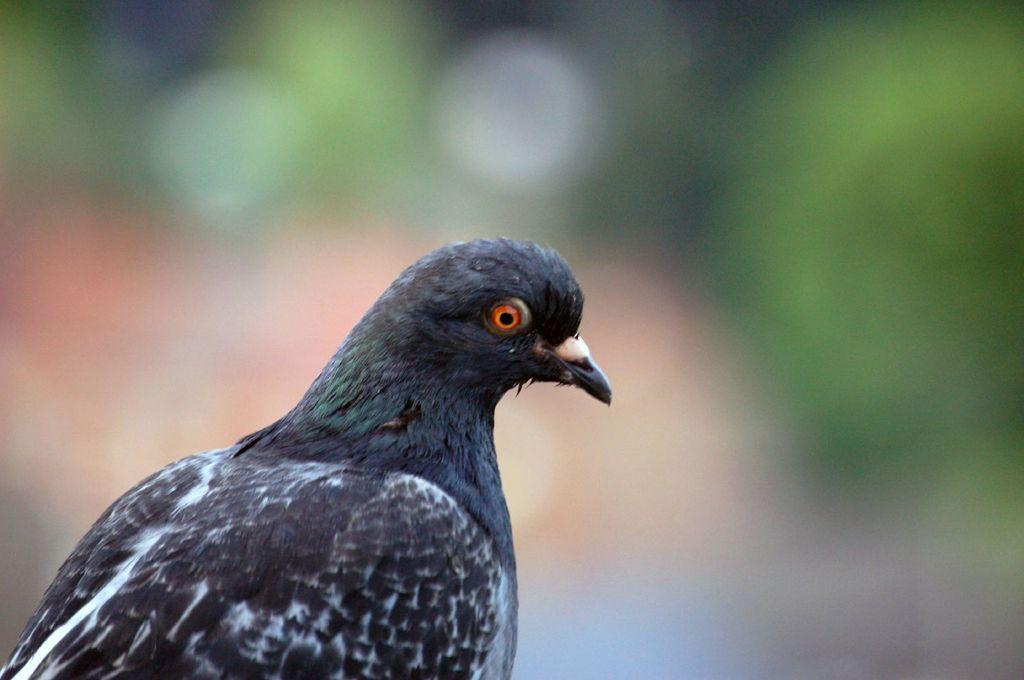What type of animal is the main subject of the image? There is a bird in the image. Where is the bird located in the image? The bird is in the front of the image. What can be observed about the background of the image? The background of the image is blurred. What type of bone can be seen in the image? There is no bone present in the image; it features a bird in the front with a blurred background. 